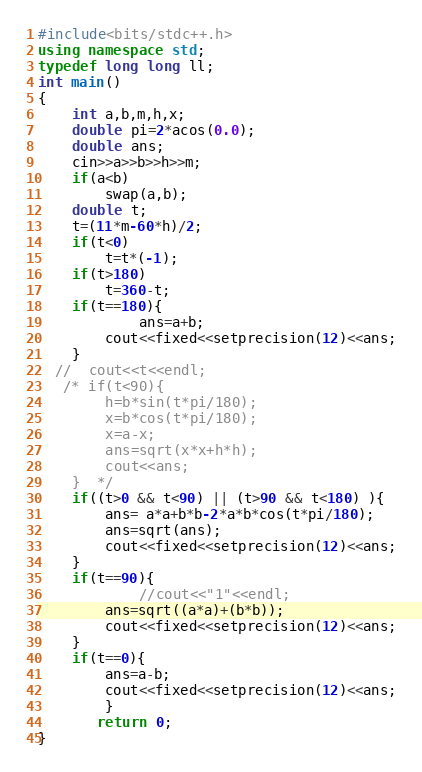Convert code to text. <code><loc_0><loc_0><loc_500><loc_500><_C++_>#include<bits/stdc++.h>
using namespace std;
typedef long long ll;
int main()
{
    int a,b,m,h,x;
    double pi=2*acos(0.0);
    double ans;
    cin>>a>>b>>h>>m;
    if(a<b)
        swap(a,b);
    double t;
    t=(11*m-60*h)/2;
    if(t<0)
        t=t*(-1);
    if(t>180)
        t=360-t;
    if(t==180){
            ans=a+b;
        cout<<fixed<<setprecision(12)<<ans;
    }
  //  cout<<t<<endl;
   /* if(t<90){
        h=b*sin(t*pi/180);
        x=b*cos(t*pi/180);
        x=a-x;
        ans=sqrt(x*x+h*h);
        cout<<ans;
    }  */
    if((t>0 && t<90) || (t>90 && t<180) ){
        ans= a*a+b*b-2*a*b*cos(t*pi/180);
        ans=sqrt(ans);
        cout<<fixed<<setprecision(12)<<ans;
    }
    if(t==90){
            //cout<<"1"<<endl;
        ans=sqrt((a*a)+(b*b));
        cout<<fixed<<setprecision(12)<<ans;
    }
    if(t==0){
        ans=a-b;
        cout<<fixed<<setprecision(12)<<ans;
        }
       return 0;
}
</code> 